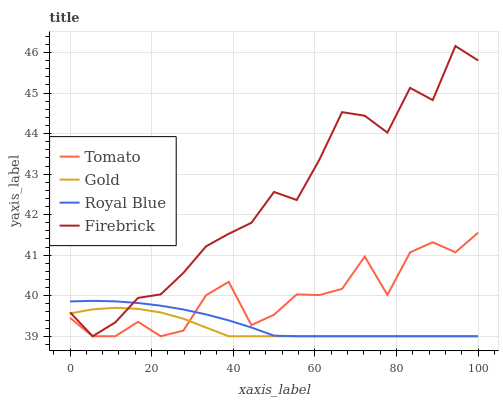Does Gold have the minimum area under the curve?
Answer yes or no. Yes. Does Firebrick have the maximum area under the curve?
Answer yes or no. Yes. Does Royal Blue have the minimum area under the curve?
Answer yes or no. No. Does Royal Blue have the maximum area under the curve?
Answer yes or no. No. Is Royal Blue the smoothest?
Answer yes or no. Yes. Is Tomato the roughest?
Answer yes or no. Yes. Is Firebrick the smoothest?
Answer yes or no. No. Is Firebrick the roughest?
Answer yes or no. No. Does Tomato have the lowest value?
Answer yes or no. Yes. Does Firebrick have the highest value?
Answer yes or no. Yes. Does Royal Blue have the highest value?
Answer yes or no. No. Does Royal Blue intersect Gold?
Answer yes or no. Yes. Is Royal Blue less than Gold?
Answer yes or no. No. Is Royal Blue greater than Gold?
Answer yes or no. No. 